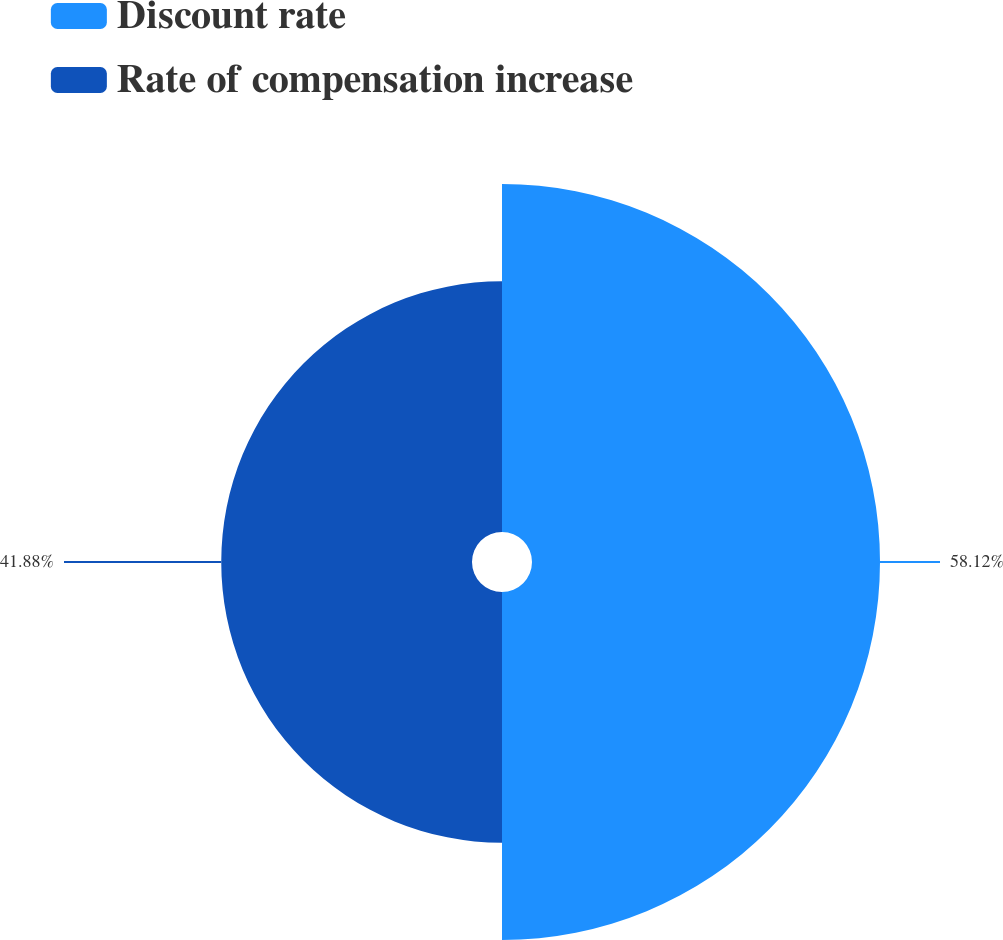Convert chart. <chart><loc_0><loc_0><loc_500><loc_500><pie_chart><fcel>Discount rate<fcel>Rate of compensation increase<nl><fcel>58.12%<fcel>41.88%<nl></chart> 